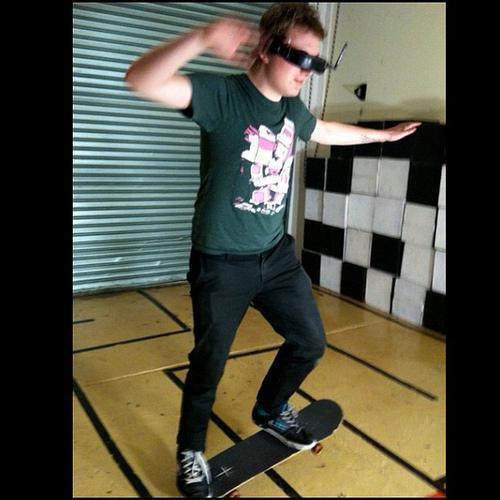How many people are there?
Give a very brief answer. 1. 